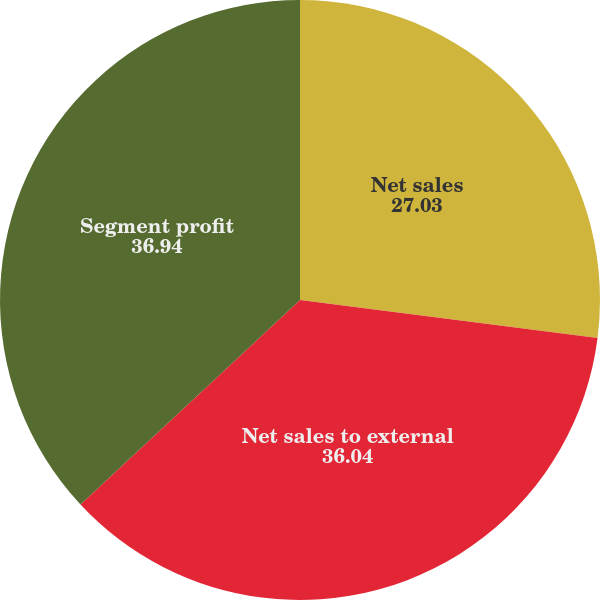Convert chart to OTSL. <chart><loc_0><loc_0><loc_500><loc_500><pie_chart><fcel>Net sales<fcel>Net sales to external<fcel>Segment profit<nl><fcel>27.03%<fcel>36.04%<fcel>36.94%<nl></chart> 